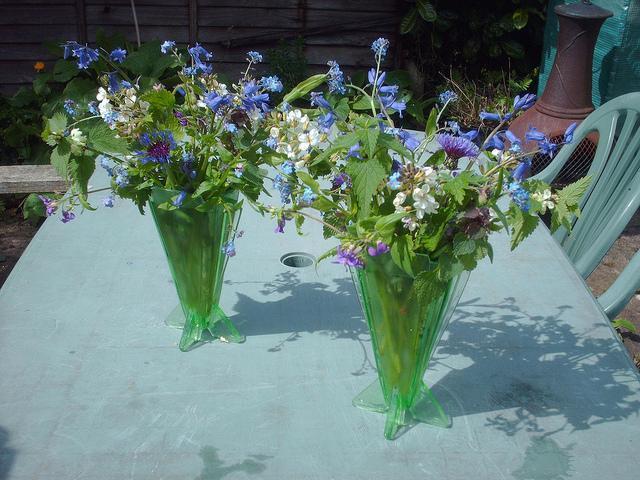How many vases on the table?
Give a very brief answer. 2. How many vases are there?
Give a very brief answer. 2. How many potted plants are in the picture?
Give a very brief answer. 2. 